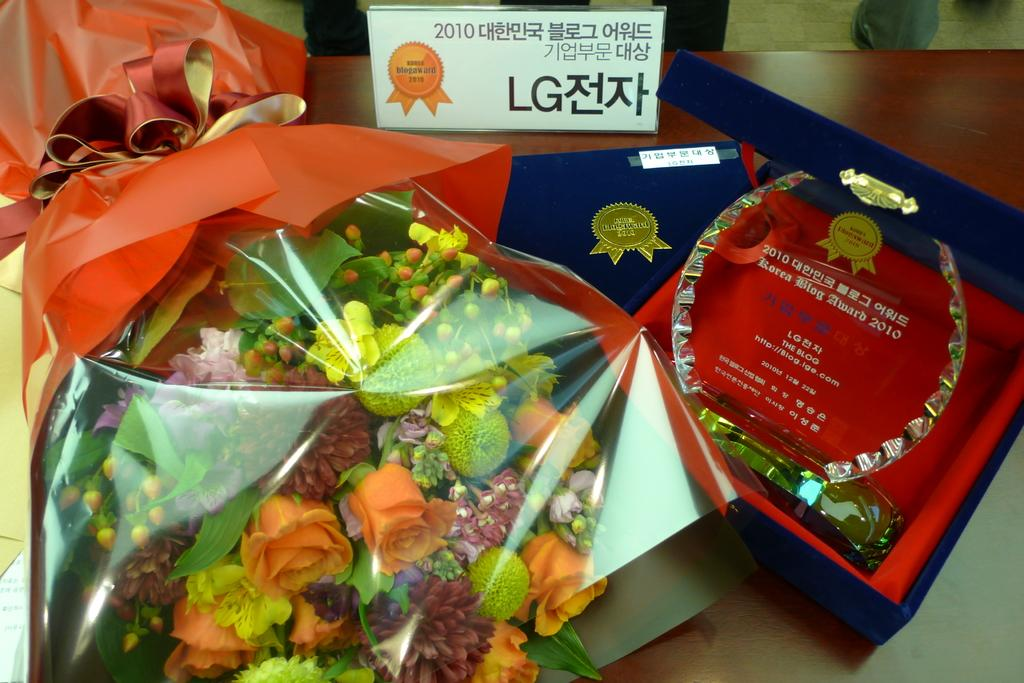What is the color of the table in the image? The table in the image is brown-colored. What is placed on the table? There is a flower bouquet, a blue-colored box, and a white-colored board on the table. What is inside the blue-colored box? There is an object inside the blue-colored box. What is written on the white-colored board? Something is written on the white-colored board. What flavor of cast can be seen on the white-colored board? There is no cast or flavor mentioned in the image. The white-colored board has something written on it, but it is not related to a cast or flavor. 